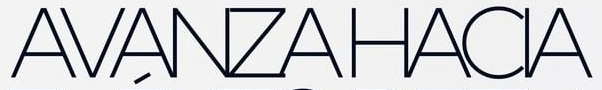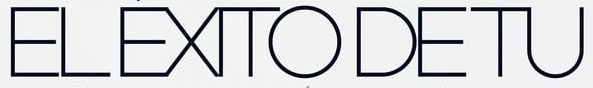Identify the words shown in these images in order, separated by a semicolon. AVANZAHACIA; ELÉXITODETU 